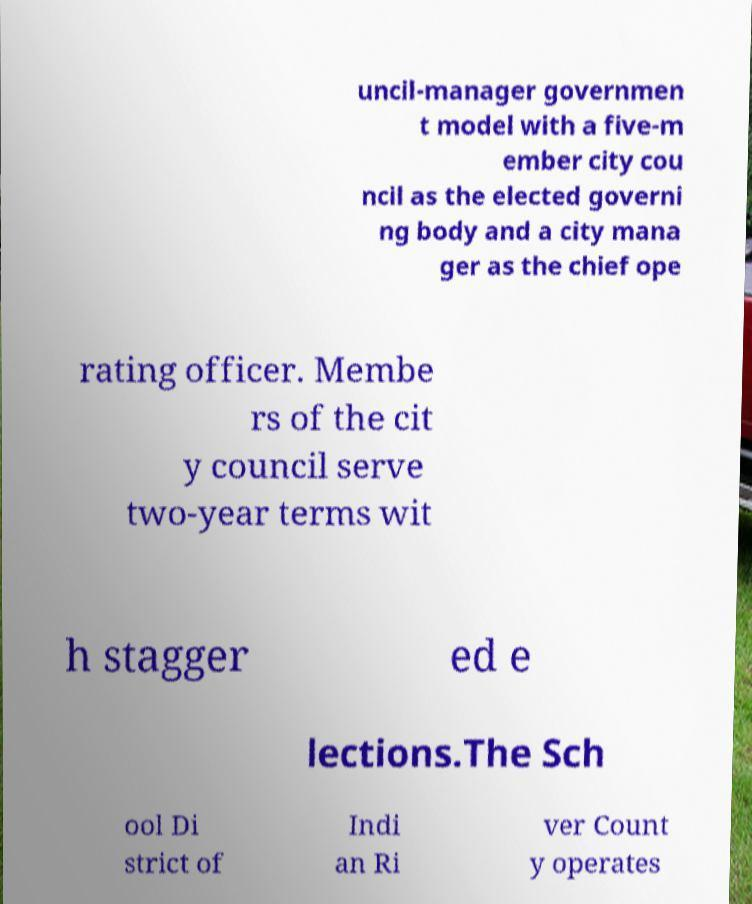For documentation purposes, I need the text within this image transcribed. Could you provide that? uncil-manager governmen t model with a five-m ember city cou ncil as the elected governi ng body and a city mana ger as the chief ope rating officer. Membe rs of the cit y council serve two-year terms wit h stagger ed e lections.The Sch ool Di strict of Indi an Ri ver Count y operates 